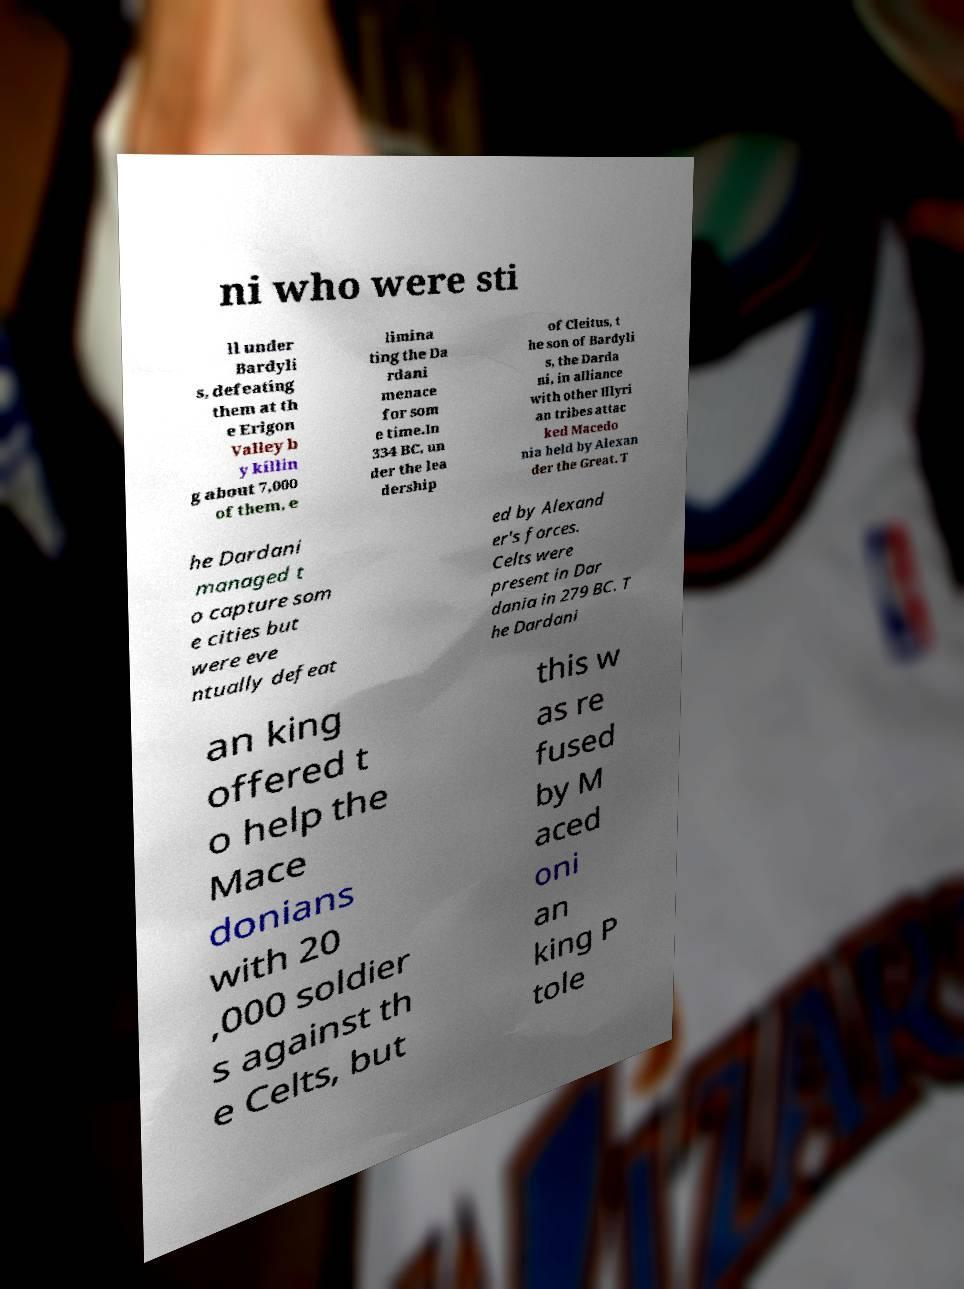There's text embedded in this image that I need extracted. Can you transcribe it verbatim? ni who were sti ll under Bardyli s, defeating them at th e Erigon Valley b y killin g about 7,000 of them, e limina ting the Da rdani menace for som e time.In 334 BC, un der the lea dership of Cleitus, t he son of Bardyli s, the Darda ni, in alliance with other Illyri an tribes attac ked Macedo nia held by Alexan der the Great. T he Dardani managed t o capture som e cities but were eve ntually defeat ed by Alexand er's forces. Celts were present in Dar dania in 279 BC. T he Dardani an king offered t o help the Mace donians with 20 ,000 soldier s against th e Celts, but this w as re fused by M aced oni an king P tole 